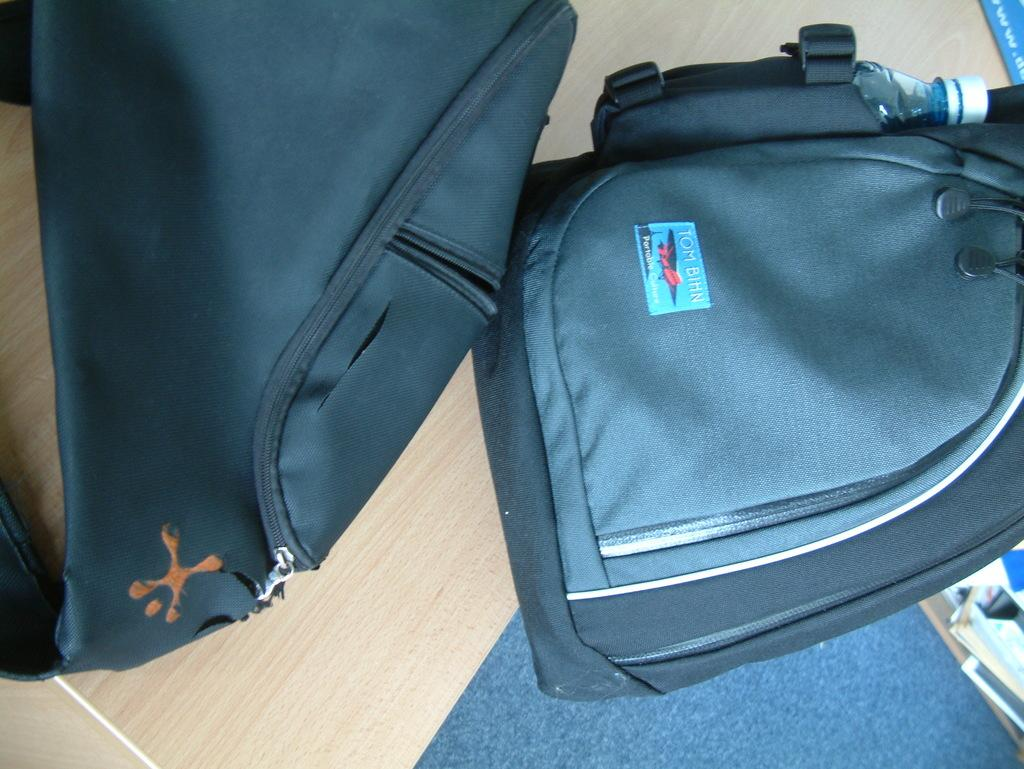What object is present in the image? There is a backpack in the image. What color is the backpack? The backpack is blue in color. Is there a house made of pickles in the image? No, there is no house made of pickles in the image. 